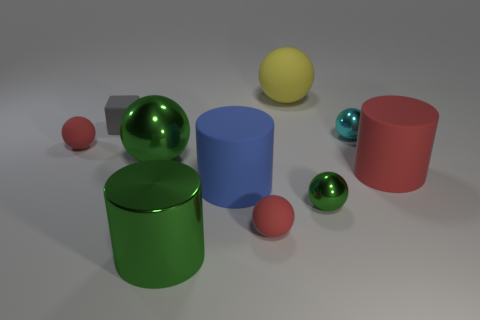Subtract all large matte cylinders. How many cylinders are left? 1 Subtract 3 cylinders. How many cylinders are left? 0 Subtract all cyan spheres. How many spheres are left? 5 Subtract all blocks. How many objects are left? 9 Subtract all red matte blocks. Subtract all tiny red things. How many objects are left? 8 Add 8 large green cylinders. How many large green cylinders are left? 9 Add 7 small cyan spheres. How many small cyan spheres exist? 8 Subtract 0 purple cubes. How many objects are left? 10 Subtract all cyan cylinders. Subtract all gray balls. How many cylinders are left? 3 Subtract all brown blocks. How many green cylinders are left? 1 